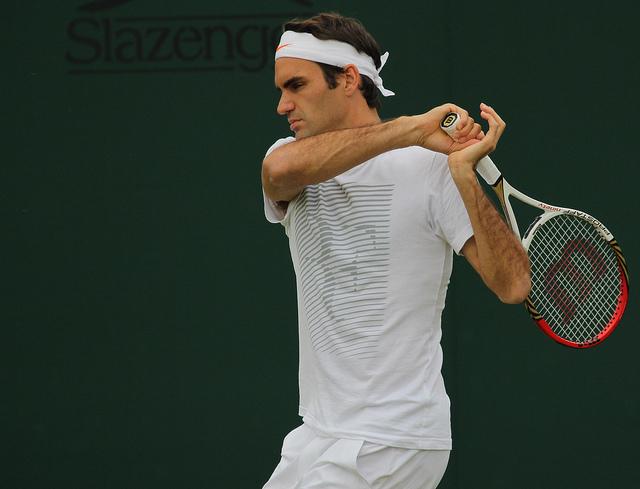Is the man wearing a wristband?
Write a very short answer. No. Is this man ready to hit the tennis ball?
Be succinct. Yes. Is he wearing a headband?
Concise answer only. Yes. What color is the mans' outfit?
Answer briefly. White. What color is the symbol on the man's head tie?
Concise answer only. Orange. 